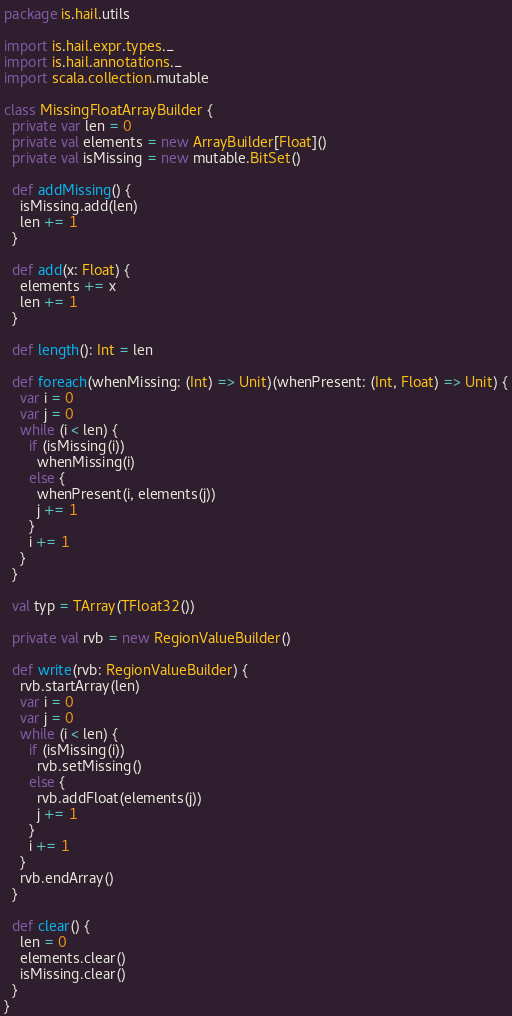<code> <loc_0><loc_0><loc_500><loc_500><_Scala_>package is.hail.utils

import is.hail.expr.types._
import is.hail.annotations._
import scala.collection.mutable

class MissingFloatArrayBuilder {
  private var len = 0
  private val elements = new ArrayBuilder[Float]()
  private val isMissing = new mutable.BitSet()

  def addMissing() {
    isMissing.add(len)
    len += 1
  }

  def add(x: Float) {
    elements += x
    len += 1
  }

  def length(): Int = len

  def foreach(whenMissing: (Int) => Unit)(whenPresent: (Int, Float) => Unit) {
    var i = 0
    var j = 0
    while (i < len) {
      if (isMissing(i))
        whenMissing(i)
      else {
        whenPresent(i, elements(j))
        j += 1
      }
      i += 1
    }
  }

  val typ = TArray(TFloat32())

  private val rvb = new RegionValueBuilder()

  def write(rvb: RegionValueBuilder) {
    rvb.startArray(len)
    var i = 0
    var j = 0
    while (i < len) {
      if (isMissing(i))
        rvb.setMissing()
      else {
        rvb.addFloat(elements(j))
        j += 1
      }
      i += 1
    }
    rvb.endArray()
  }

  def clear() {
    len = 0
    elements.clear()
    isMissing.clear()
  }
}
</code> 